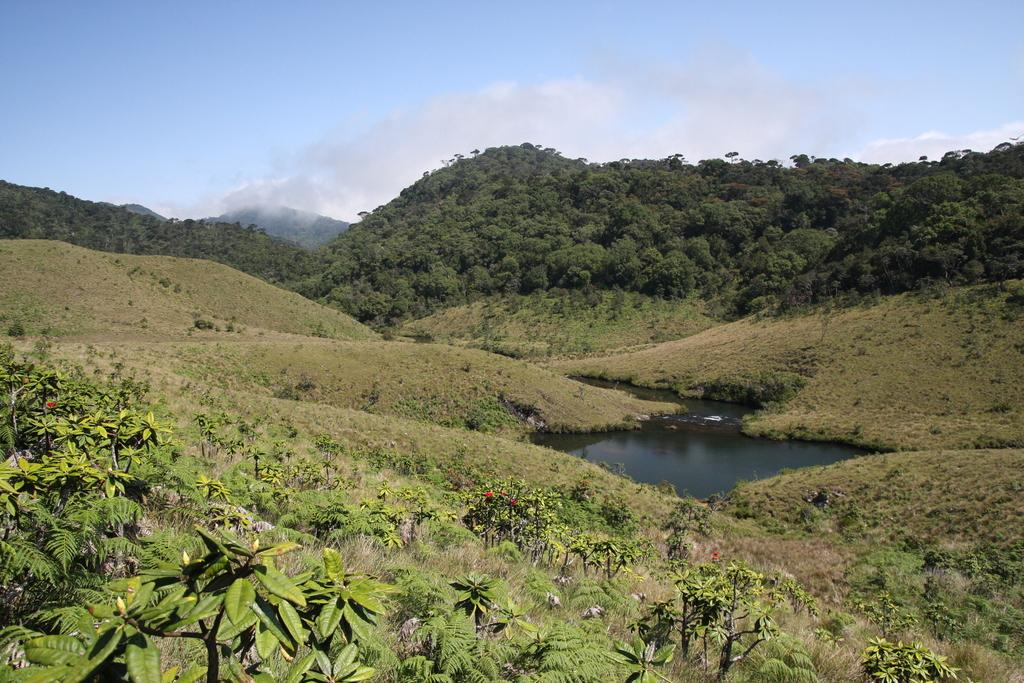What types of vegetation can be seen in the foreground of the picture? There are plants, shrubs, and grass in the foreground of the picture. What can be seen in the center of the picture? There are hills and a water body in the center of the picture. What is visible in the background of the picture? There are hills and trees in the background of the background of the picture. Are there any signs of magic or giants in the image? There is no indication of magic or giants in the image. Is there a volcano visible in the background of the image? There is no volcano present in the image; it features hills and trees in the background. 